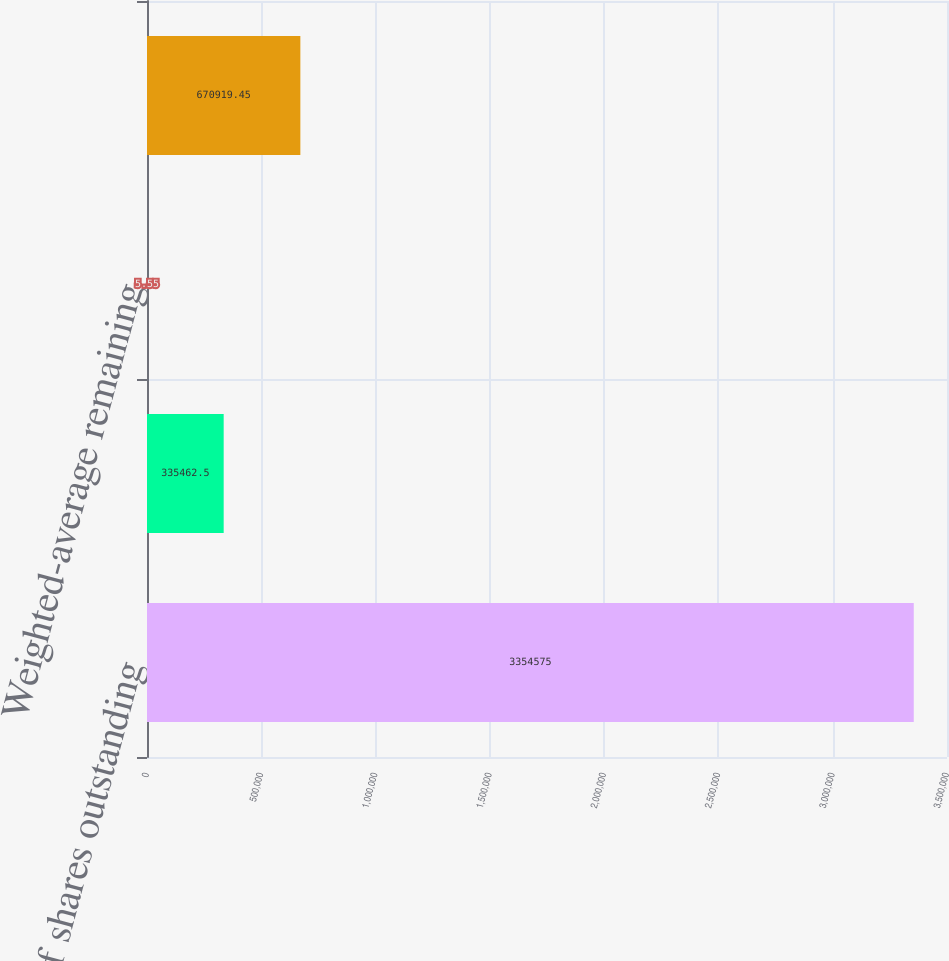<chart> <loc_0><loc_0><loc_500><loc_500><bar_chart><fcel>Number of shares outstanding<fcel>Weighted-average exercise<fcel>Weighted-average remaining<fcel>Aggregate intrinsic value<nl><fcel>3.35458e+06<fcel>335462<fcel>5.55<fcel>670919<nl></chart> 